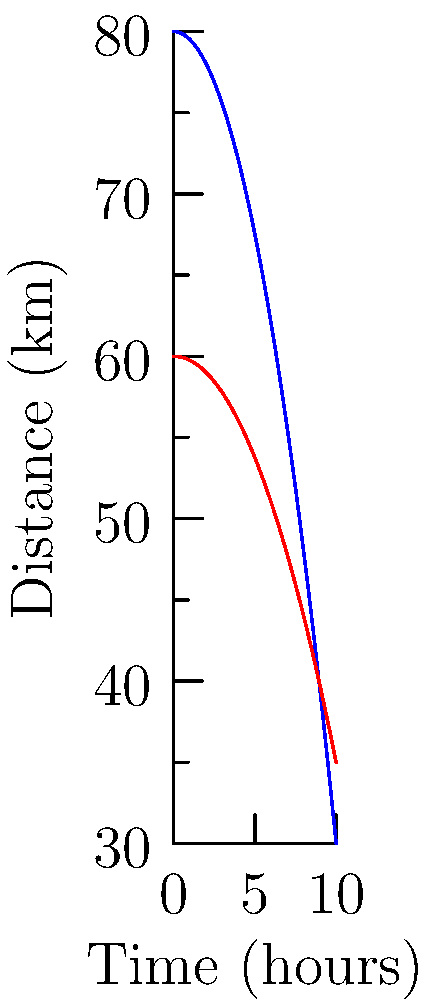Analyzing the distance-time graphs of a hydrogen-powered vehicle and a conventional vehicle, what can be inferred about the fuel efficiency of the hydrogen vehicle compared to the conventional one after 8 hours of travel? To analyze the fuel efficiency, we need to compare the distances traveled by both vehicles after 8 hours:

1. For the hydrogen vehicle (blue curve):
   Distance = $80 - 0.5x^2$
   At x = 8 hours: $80 - 0.5(8^2) = 80 - 32 = 48$ km

2. For the conventional vehicle (red curve):
   Distance = $60 - 0.25x^2$
   At x = 8 hours: $60 - 0.25(8^2) = 60 - 16 = 44$ km

3. The hydrogen vehicle has traveled 48 km compared to 44 km for the conventional vehicle.

4. The hydrogen vehicle has covered a greater distance in the same time, indicating better fuel efficiency.

5. The difference in distance is 48 km - 44 km = 4 km, which is about 9% more distance covered by the hydrogen vehicle.

6. The curves also show that the hydrogen vehicle maintains a higher speed for a longer duration before deceleration becomes significant, suggesting better sustained performance.
Answer: The hydrogen vehicle is approximately 9% more fuel-efficient after 8 hours of travel. 